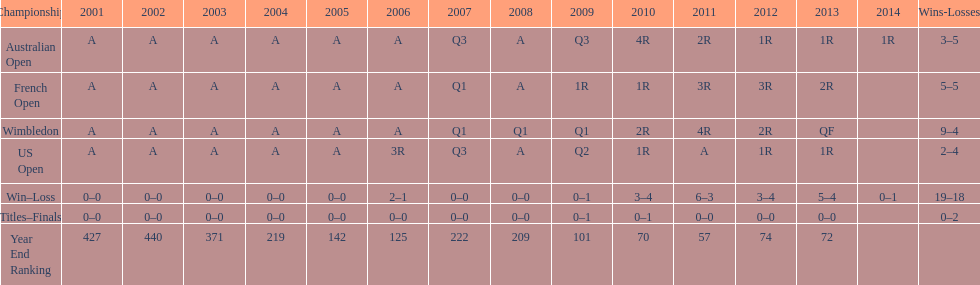Which year end ranking was higher, 2004 or 2011? 2011. Parse the full table. {'header': ['Championship', '2001', '2002', '2003', '2004', '2005', '2006', '2007', '2008', '2009', '2010', '2011', '2012', '2013', '2014', 'Wins-Losses'], 'rows': [['Australian Open', 'A', 'A', 'A', 'A', 'A', 'A', 'Q3', 'A', 'Q3', '4R', '2R', '1R', '1R', '1R', '3–5'], ['French Open', 'A', 'A', 'A', 'A', 'A', 'A', 'Q1', 'A', '1R', '1R', '3R', '3R', '2R', '', '5–5'], ['Wimbledon', 'A', 'A', 'A', 'A', 'A', 'A', 'Q1', 'Q1', 'Q1', '2R', '4R', '2R', 'QF', '', '9–4'], ['US Open', 'A', 'A', 'A', 'A', 'A', '3R', 'Q3', 'A', 'Q2', '1R', 'A', '1R', '1R', '', '2–4'], ['Win–Loss', '0–0', '0–0', '0–0', '0–0', '0–0', '2–1', '0–0', '0–0', '0–1', '3–4', '6–3', '3–4', '5–4', '0–1', '19–18'], ['Titles–Finals', '0–0', '0–0', '0–0', '0–0', '0–0', '0–0', '0–0', '0–0', '0–1', '0–1', '0–0', '0–0', '0–0', '', '0–2'], ['Year End Ranking', '427', '440', '371', '219', '142', '125', '222', '209', '101', '70', '57', '74', '72', '', '']]} 